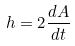<formula> <loc_0><loc_0><loc_500><loc_500>h = 2 \frac { d A } { d t }</formula> 